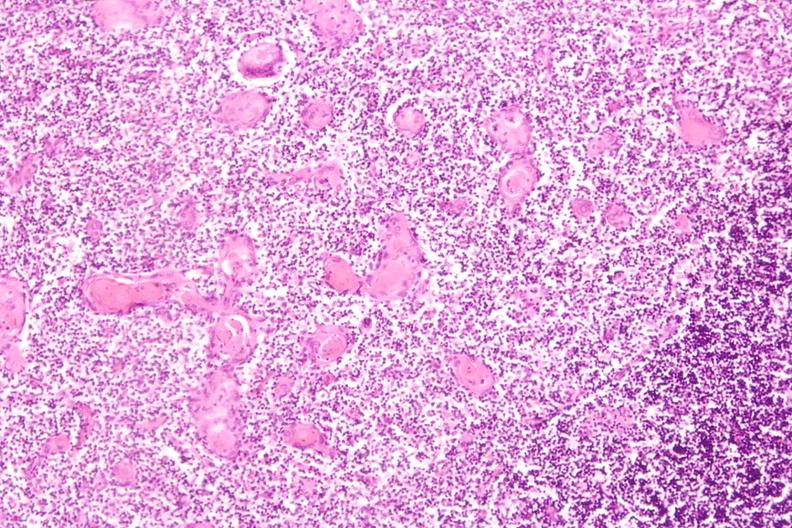do stress induce involution in baby with hyaline membrane disease?
Answer the question using a single word or phrase. Yes 